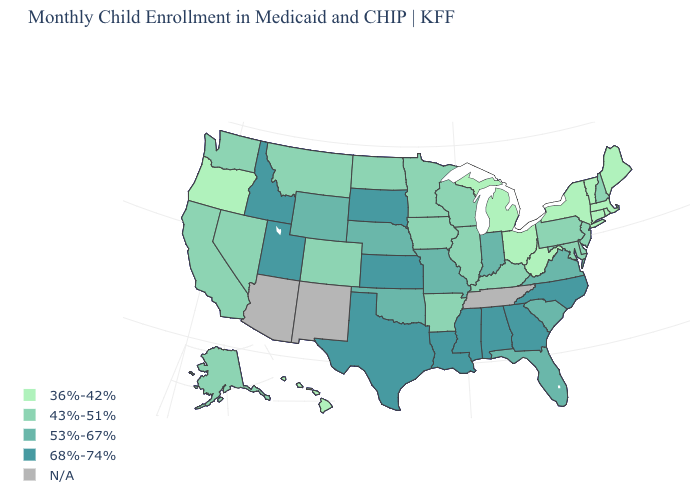Is the legend a continuous bar?
Short answer required. No. Which states have the lowest value in the MidWest?
Quick response, please. Michigan, Ohio. Name the states that have a value in the range 36%-42%?
Short answer required. Connecticut, Hawaii, Maine, Massachusetts, Michigan, New York, Ohio, Oregon, Rhode Island, Vermont, West Virginia. How many symbols are there in the legend?
Be succinct. 5. How many symbols are there in the legend?
Give a very brief answer. 5. Name the states that have a value in the range N/A?
Keep it brief. Arizona, New Mexico, Tennessee. What is the highest value in the Northeast ?
Give a very brief answer. 43%-51%. What is the lowest value in the West?
Be succinct. 36%-42%. Name the states that have a value in the range 53%-67%?
Be succinct. Florida, Indiana, Missouri, Nebraska, Oklahoma, South Carolina, Virginia, Wyoming. Among the states that border Indiana , does Michigan have the highest value?
Write a very short answer. No. Name the states that have a value in the range 36%-42%?
Quick response, please. Connecticut, Hawaii, Maine, Massachusetts, Michigan, New York, Ohio, Oregon, Rhode Island, Vermont, West Virginia. Does New Jersey have the highest value in the USA?
Quick response, please. No. What is the highest value in states that border Montana?
Answer briefly. 68%-74%. What is the value of Indiana?
Write a very short answer. 53%-67%. 